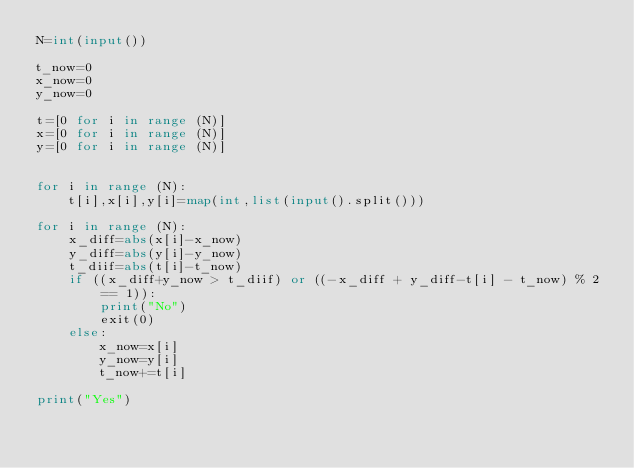Convert code to text. <code><loc_0><loc_0><loc_500><loc_500><_Python_>N=int(input())

t_now=0
x_now=0
y_now=0

t=[0 for i in range (N)]
x=[0 for i in range (N)]
y=[0 for i in range (N)]


for i in range (N):
    t[i],x[i],y[i]=map(int,list(input().split()))

for i in range (N):
    x_diff=abs(x[i]-x_now)
    y_diff=abs(y[i]-y_now)
    t_diif=abs(t[i]-t_now)
    if ((x_diff+y_now > t_diif) or ((-x_diff + y_diff-t[i] - t_now) % 2 == 1)):
        print("No")
        exit(0)
    else:
        x_now=x[i]
        y_now=y[i]
        t_now+=t[i]

print("Yes")</code> 